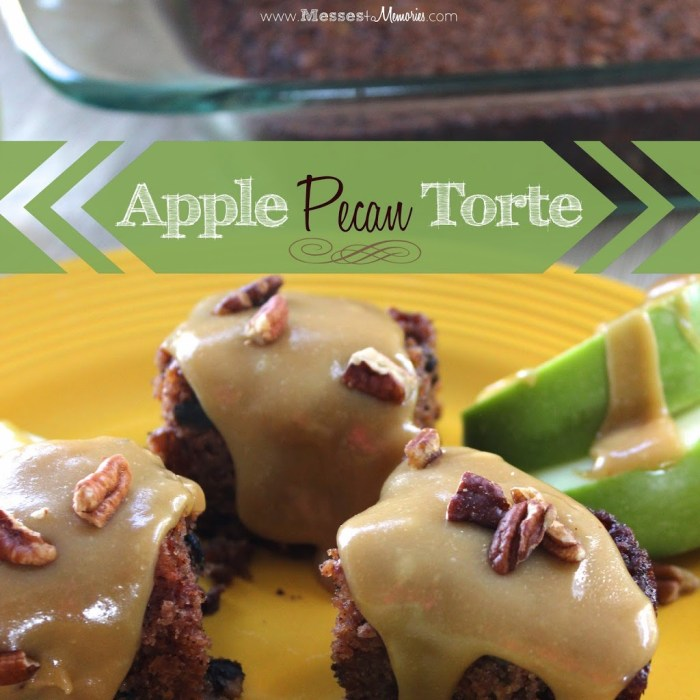Considering the elements presented in the image, what could be the main flavor profile of the dessert, and how do the garnish and topping choices complement the overall taste experience? The main flavor profile of the dessert suggested by the image would likely be a blend of apple and pecan, as indicated by the visible ingredients. The caramel glaze topping adds a sweet and rich layer, which typically pairs well with the nutty crunch of pecans and the tart sweetness of the apple slices. The garnish of fresh apple slices not only provides a textural contrast to the softness of the baked items but also reinforces the apple flavor in the dessert, suggesting a balance between sweetness and acidity, richness, and freshness. 